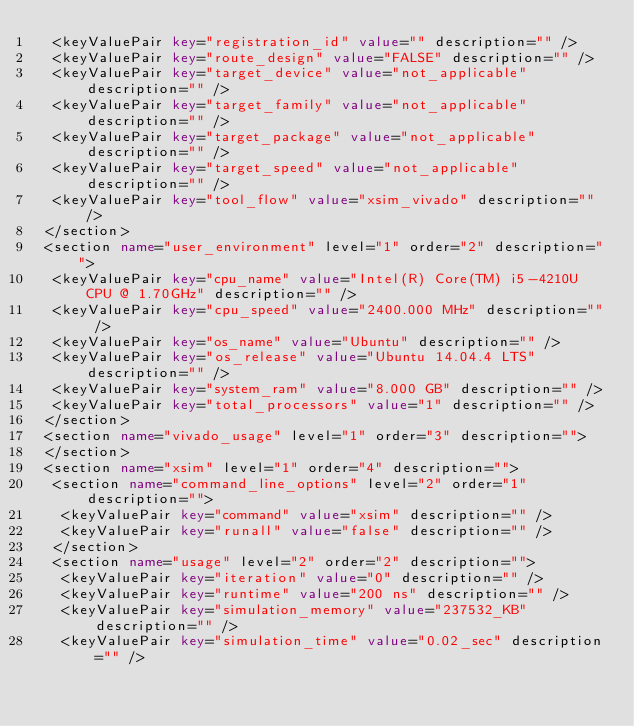<code> <loc_0><loc_0><loc_500><loc_500><_XML_>  <keyValuePair key="registration_id" value="" description="" />
  <keyValuePair key="route_design" value="FALSE" description="" />
  <keyValuePair key="target_device" value="not_applicable" description="" />
  <keyValuePair key="target_family" value="not_applicable" description="" />
  <keyValuePair key="target_package" value="not_applicable" description="" />
  <keyValuePair key="target_speed" value="not_applicable" description="" />
  <keyValuePair key="tool_flow" value="xsim_vivado" description="" />
 </section>
 <section name="user_environment" level="1" order="2" description="">
  <keyValuePair key="cpu_name" value="Intel(R) Core(TM) i5-4210U CPU @ 1.70GHz" description="" />
  <keyValuePair key="cpu_speed" value="2400.000 MHz" description="" />
  <keyValuePair key="os_name" value="Ubuntu" description="" />
  <keyValuePair key="os_release" value="Ubuntu 14.04.4 LTS" description="" />
  <keyValuePair key="system_ram" value="8.000 GB" description="" />
  <keyValuePair key="total_processors" value="1" description="" />
 </section>
 <section name="vivado_usage" level="1" order="3" description="">
 </section>
 <section name="xsim" level="1" order="4" description="">
  <section name="command_line_options" level="2" order="1" description="">
   <keyValuePair key="command" value="xsim" description="" />
   <keyValuePair key="runall" value="false" description="" />
  </section>
  <section name="usage" level="2" order="2" description="">
   <keyValuePair key="iteration" value="0" description="" />
   <keyValuePair key="runtime" value="200 ns" description="" />
   <keyValuePair key="simulation_memory" value="237532_KB" description="" />
   <keyValuePair key="simulation_time" value="0.02_sec" description="" /></code> 